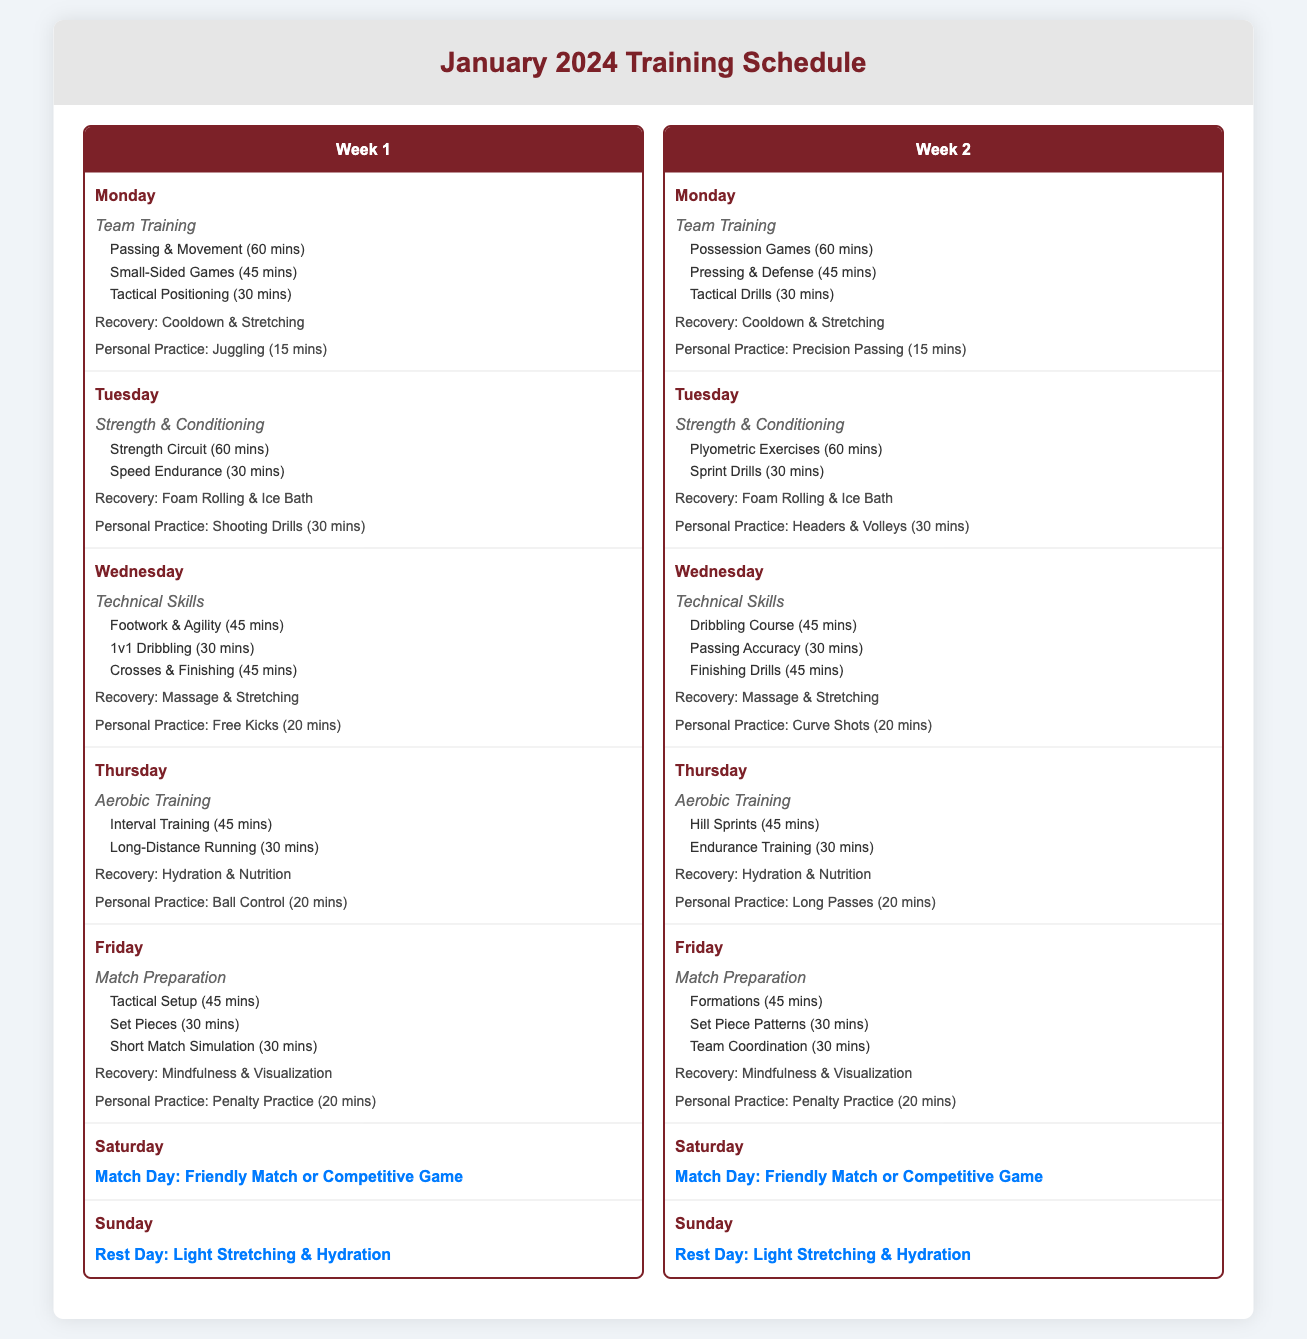What is the total number of training sessions in Week 1? The document lists 6 training sessions in Week 1: Monday to Friday, excluding Match Day and Rest Day.
Answer: 6 What type of training is scheduled for Tuesday of Week 2? Tuesday of Week 2 lists "Strength & Conditioning" as the session type.
Answer: Strength & Conditioning What is the duration of the "Small-Sided Games" drill on Monday? The drill "Small-Sided Games" on Monday has a duration of 45 minutes.
Answer: 45 mins Which day is designated as a Rest Day in Week 1? The document indicates that Sunday is designated as a Rest Day in Week 1.
Answer: Sunday How many drills are scheduled on Friday of Week 1? There are 3 drills listed for Friday of Week 1: Tactical Setup, Set Pieces, and Short Match Simulation.
Answer: 3 What is the personal practice on Wednesday of Week 2? The personal practice on Wednesday of Week 2 is "Curve Shots" which lasts 20 minutes.
Answer: Curve Shots What recovery activity is mentioned for the "Match Preparation" session on Friday? "Mindfulness & Visualization" is the recovery activity mentioned for the match preparation session on Friday.
Answer: Mindfulness & Visualization What is the first drill listed for Monday of Week 1? The first drill listed for Monday of Week 1 is "Passing & Movement".
Answer: Passing & Movement On which day is the "Friendly Match or Competitive Game" scheduled? The match is scheduled for Saturday.
Answer: Saturday 